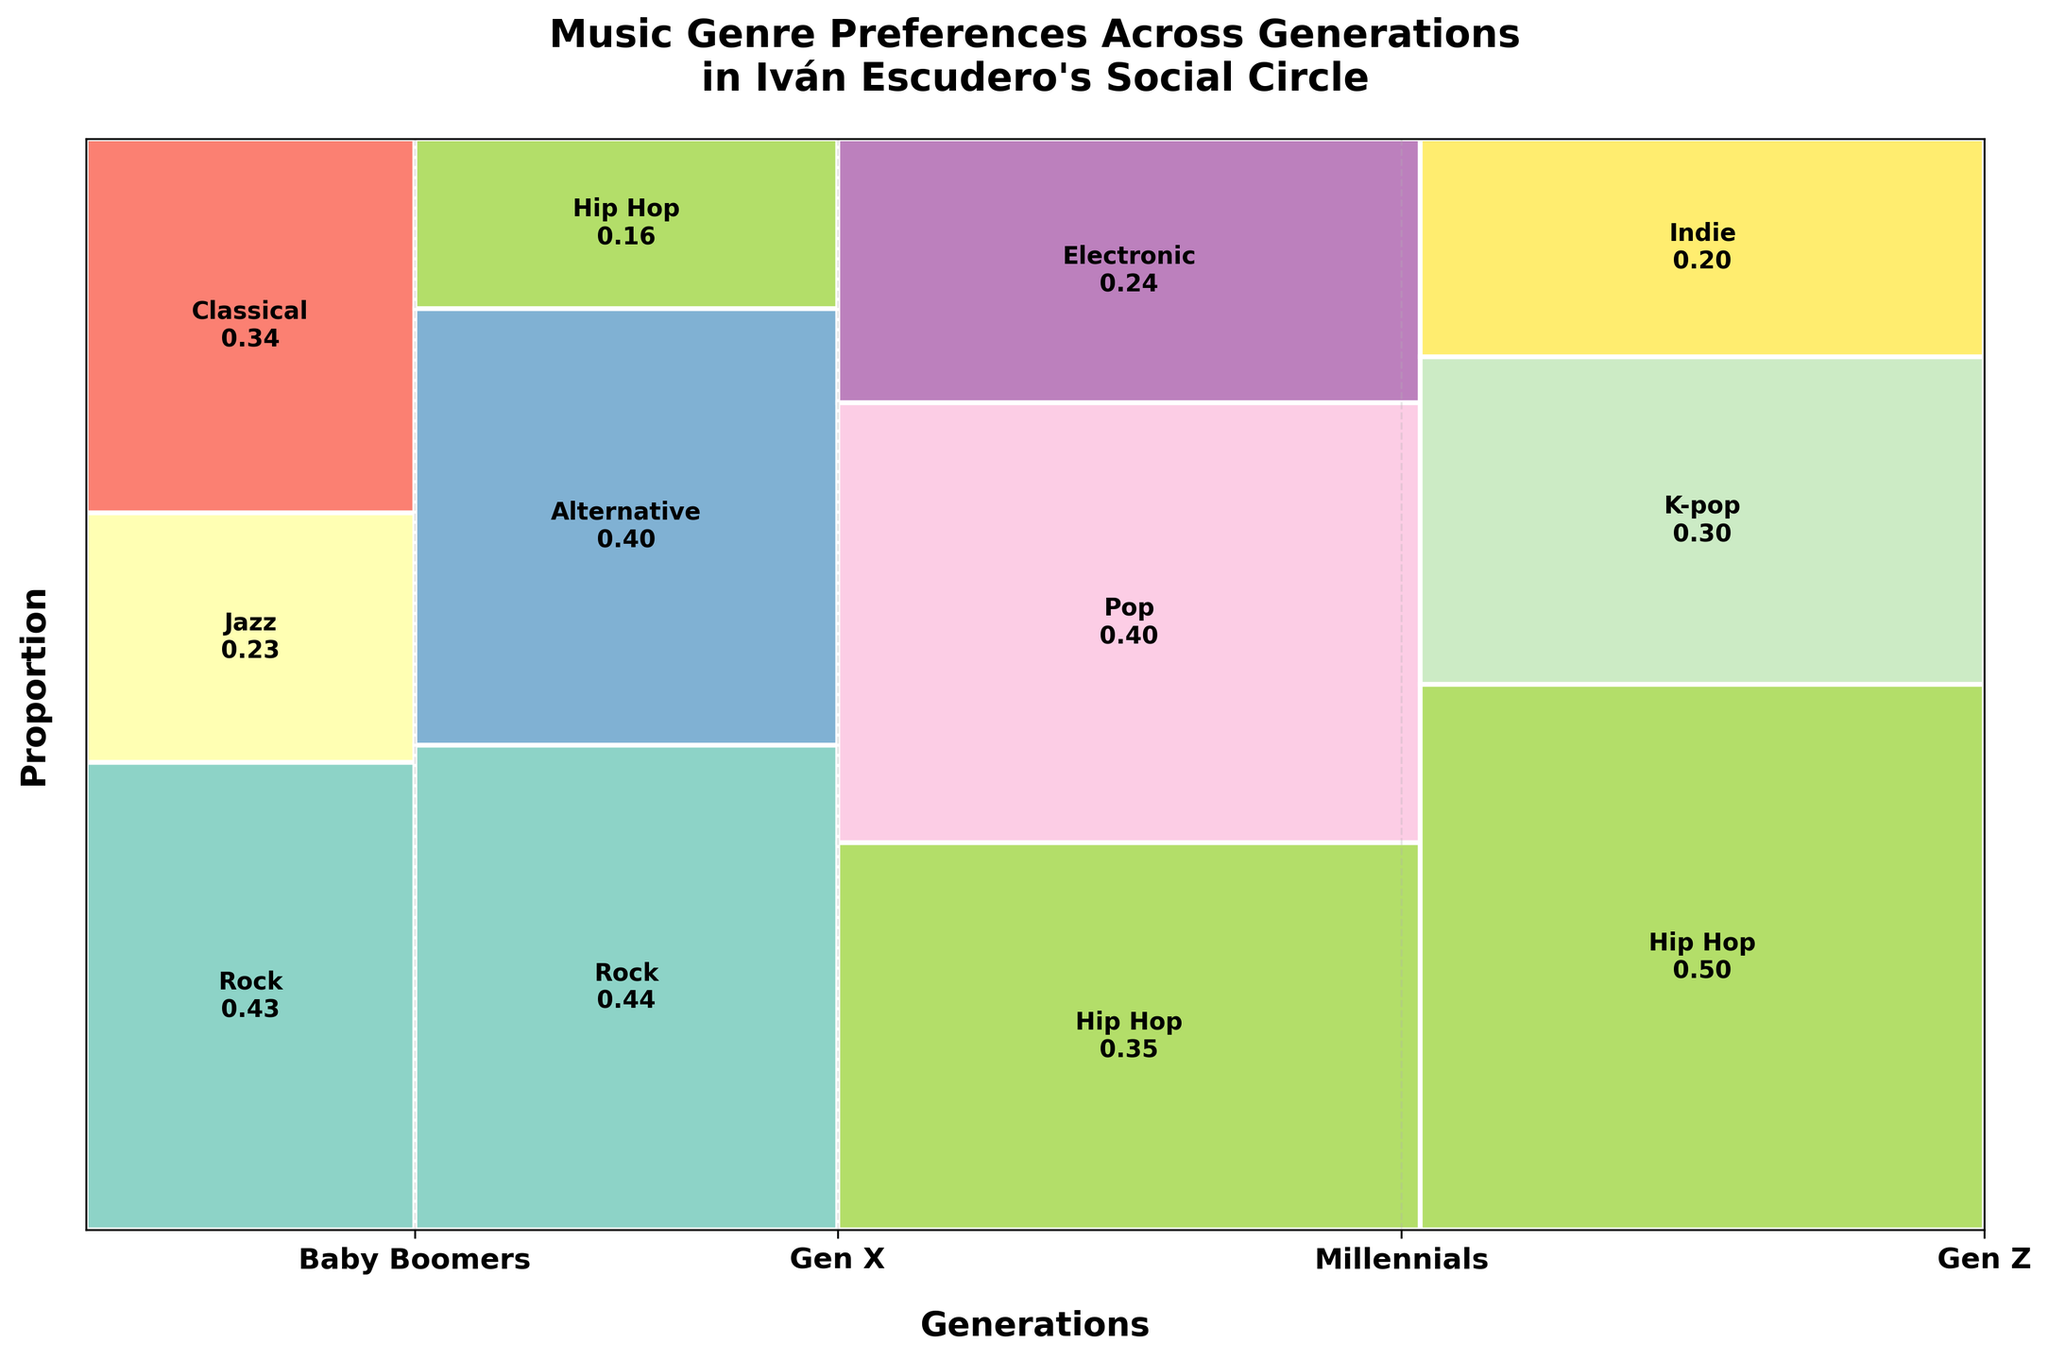What is the most preferred genre among Baby Boomers? Look at the section labeled "Baby Boomers". The largest rectangle in this section represents the most preferred genre, which is Rock with 15 counts.
Answer: Rock Which generation has the highest preference for Hip Hop? Examine the height of rectangles labeled "Hip Hop" across different generations. The tallest rectangle is in the "Gen Z" section, indicating the highest preference.
Answer: Gen Z How many genres are represented in the figure? Count the distinct genres mentioned in the sections across all generations (Rock, Jazz, Classical, Alternative, Hip Hop, Pop, Electronic, K-pop, Indie).
Answer: 9 Which generation has the most diverse music preferences in terms of the number of genres represented? Compare the number of different genres in each generation. "Gen X" has Rock, Alternative, and Hip Hop, totaling 3 genres. "Gen Z" and "Millennials" both also have 3 genres, and "Baby Boomers" have 3 as well. They are equal in diversity.
Answer: Relations are equal What is the proportion of Millennials who prefer Pop music? Look at the section labeled "Millennials", find the rectangle for "Pop", and check its height relative to the entire Millennials column. The text label indicates it’s approximately 0.41 (41%).
Answer: 0.41 or 41% Compare the preference for Rock music across Baby Boomers and Gen X. Check the heights of the rectangles labeled "Rock" in both "Baby Boomers" and "Gen X". "Gen X" has more preference for Rock than "Baby Boomers".
Answer: Gen X prefers Rock more Which genre has the lowest preference among Millennials? In the "Millennials" section, the shortest rectangle represents the least preferred genre. This is "Electronic" with 15 counts.
Answer: Electronic What is the overall trend in Hip Hop preference from Baby Boomers to Gen Z? Observe the rectangles labeled "Hip Hop" from Baby Boomers through each generation to Gen Z. The preference increases significantly, being the highest in Gen Z.
Answer: Increasing How does the preference for Classical music among Baby Boomers compare to Jazz? Look at the "Baby Boomers" section: Classical has a taller rectangle than Jazz, indicating higher preference.
Answer: Classical > Jazz 